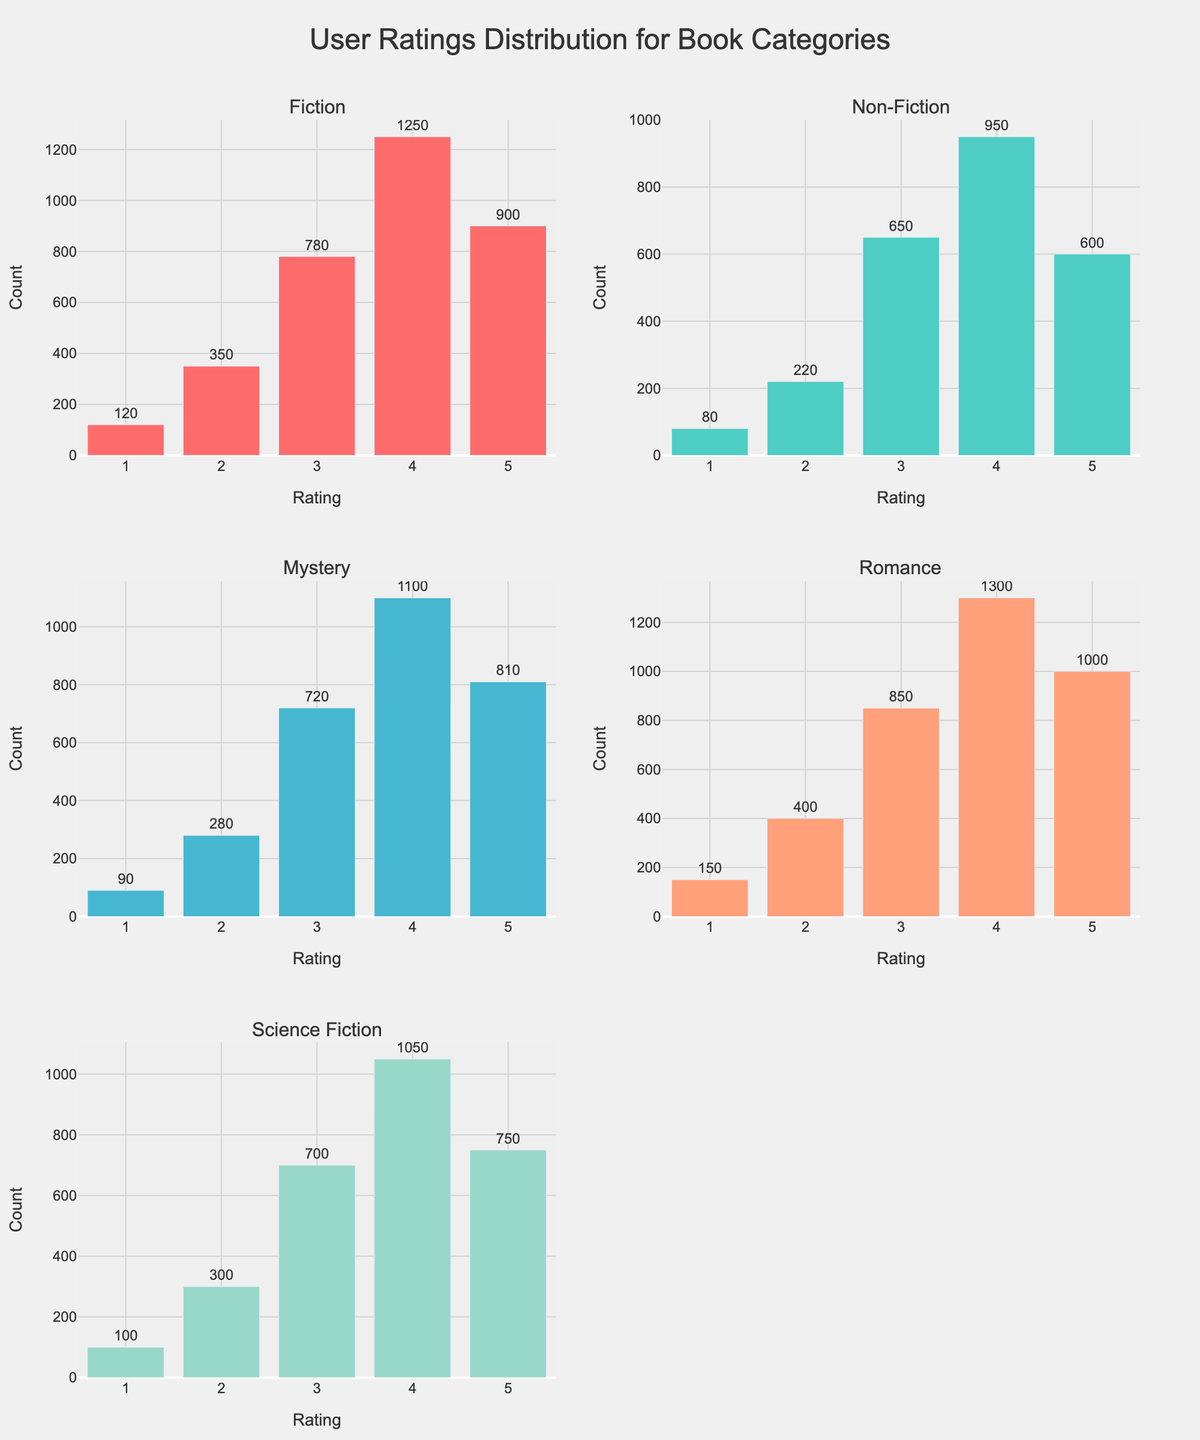What's the title of the figure? The title is displayed prominently at the top of the figure and reads "User Ratings Distribution for Book Categories"
Answer: User Ratings Distribution for Book Categories How many different book categories are shown in the figure? The subplot titles indicate the number of distinct book categories. Each subplot represents a different category
Answer: 5 Which rating has the highest count in the Fiction category? In the Fiction subplot, look for the tallest bar. The corresponding x-axis value indicates the rating with the highest count
Answer: 4 What is the total count of ratings for the Mystery category? Sum the counts of all the bars in the Mystery subplot: 90 (1-star) + 280 (2-star) + 720 (3-star) + 1100 (4-star) + 810 (5-star)
Answer: 3000 Which category has the least number of 1-star ratings? Compare the heights of the bars representing the 1-star rating across all categories. The shortest one indicates the category with the least number of 1-star ratings
Answer: Non-Fiction What is the average count of 5-star ratings among all categories? Sum the 5-star rating counts across all categories and divide by the number of categories: (900 + 600 + 810 + 1000 + 750) / 5
Answer: 812 In which category is the count for 3-star ratings the highest? Compare the heights of the bars representing the 3-star rating across all categories. The tallest one indicates the category with the highest count for 3-star ratings
Answer: Romance How do the 4-star and 5-star ratings in the Science Fiction category compare? Check the heights of the bars for the 4-star and 5-star ratings in the Science Fiction subplot. The height of the 4-star bar is taller than the 5-star bar, indicating a higher count for 4-star ratings
Answer: 4-star has higher count Which category has a more even distribution of ratings from 1 to 5? Look for the subplot where the bar heights do not vary drastically between ratings, indicating a more even distribution. The Fiction category has the least variation
Answer: Fiction What is the difference in count between the 2-star and 4-star ratings in the Non-Fiction category? Subtract the count of 2-star ratings from that of 4-star ratings in the Non-Fiction subplot: 950 (4-star) - 220 (2-star)
Answer: 730 